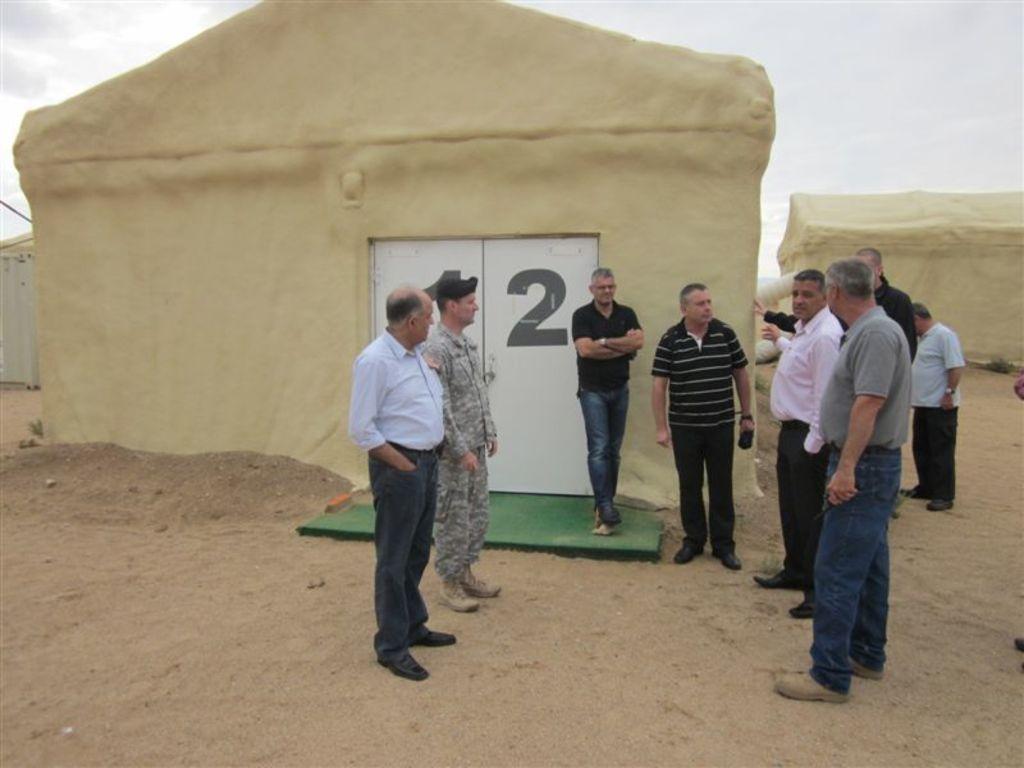Could you give a brief overview of what you see in this image? Here in this picture we can see a group of men standing on the ground and in that we can see a person wearing a military dress and a cap present and behind them we can see some shelters with doors present and we can see the sky is cloudy. 